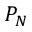Convert formula to latex. <formula><loc_0><loc_0><loc_500><loc_500>P _ { N }</formula> 